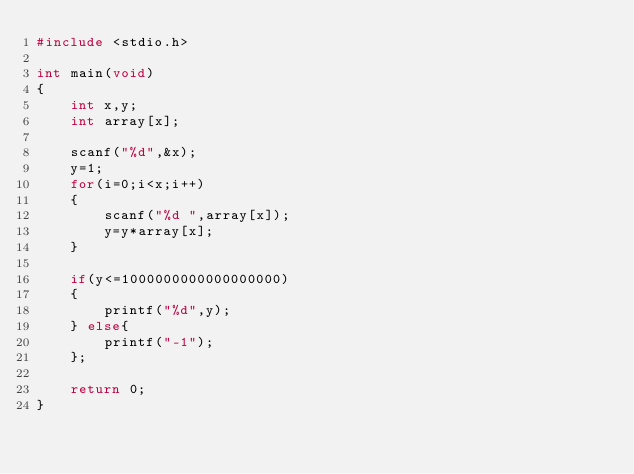Convert code to text. <code><loc_0><loc_0><loc_500><loc_500><_C_>#include <stdio.h>

int main(void)
{
    int x,y;
    int array[x];

    scanf("%d",&x);
    y=1;
    for(i=0;i<x;i++)
    {
        scanf("%d ",array[x]);
        y=y*array[x];
    }

    if(y<=1000000000000000000)
    {
        printf("%d",y);
    } else{
        printf("-1");
    };
    
    return 0;
}</code> 